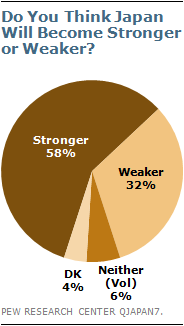Point out several critical features in this image. The smallest two pieces of the pie graph have an add up value of 10. The largest section of pie represents the strongest part of the pie. 